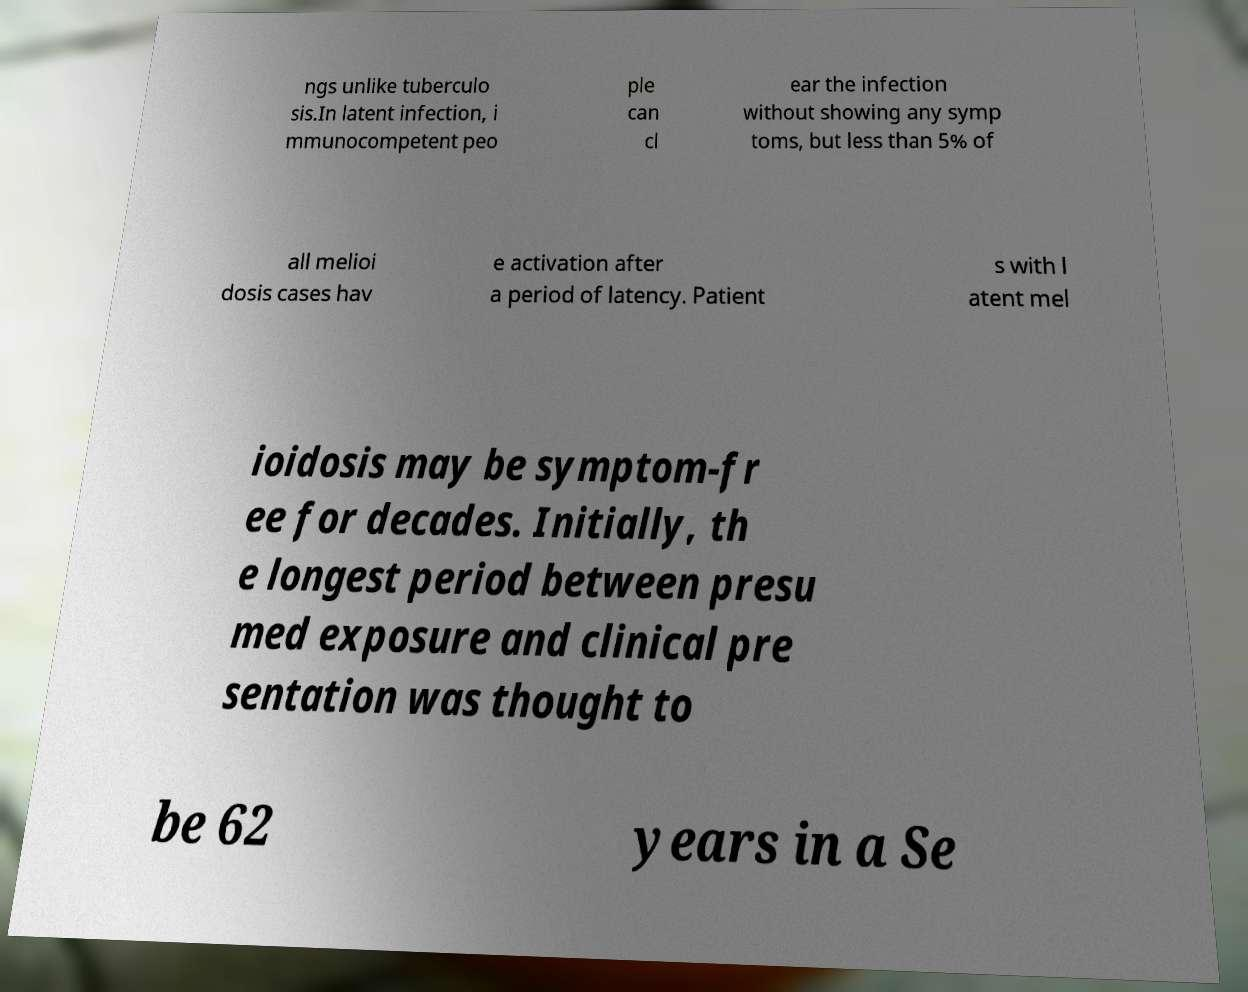What messages or text are displayed in this image? I need them in a readable, typed format. ngs unlike tuberculo sis.In latent infection, i mmunocompetent peo ple can cl ear the infection without showing any symp toms, but less than 5% of all melioi dosis cases hav e activation after a period of latency. Patient s with l atent mel ioidosis may be symptom-fr ee for decades. Initially, th e longest period between presu med exposure and clinical pre sentation was thought to be 62 years in a Se 